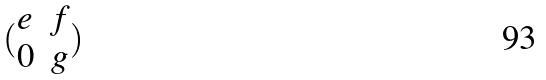Convert formula to latex. <formula><loc_0><loc_0><loc_500><loc_500>( \begin{matrix} e & f \\ 0 & g \end{matrix} )</formula> 